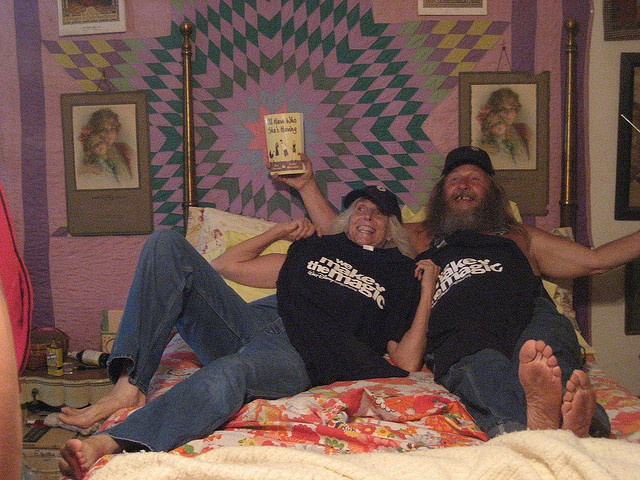Describe the objects in this image and their specific colors. I can see people in gray, black, and brown tones, people in gray, black, brown, and maroon tones, and bed in gray, tan, salmon, and brown tones in this image. 